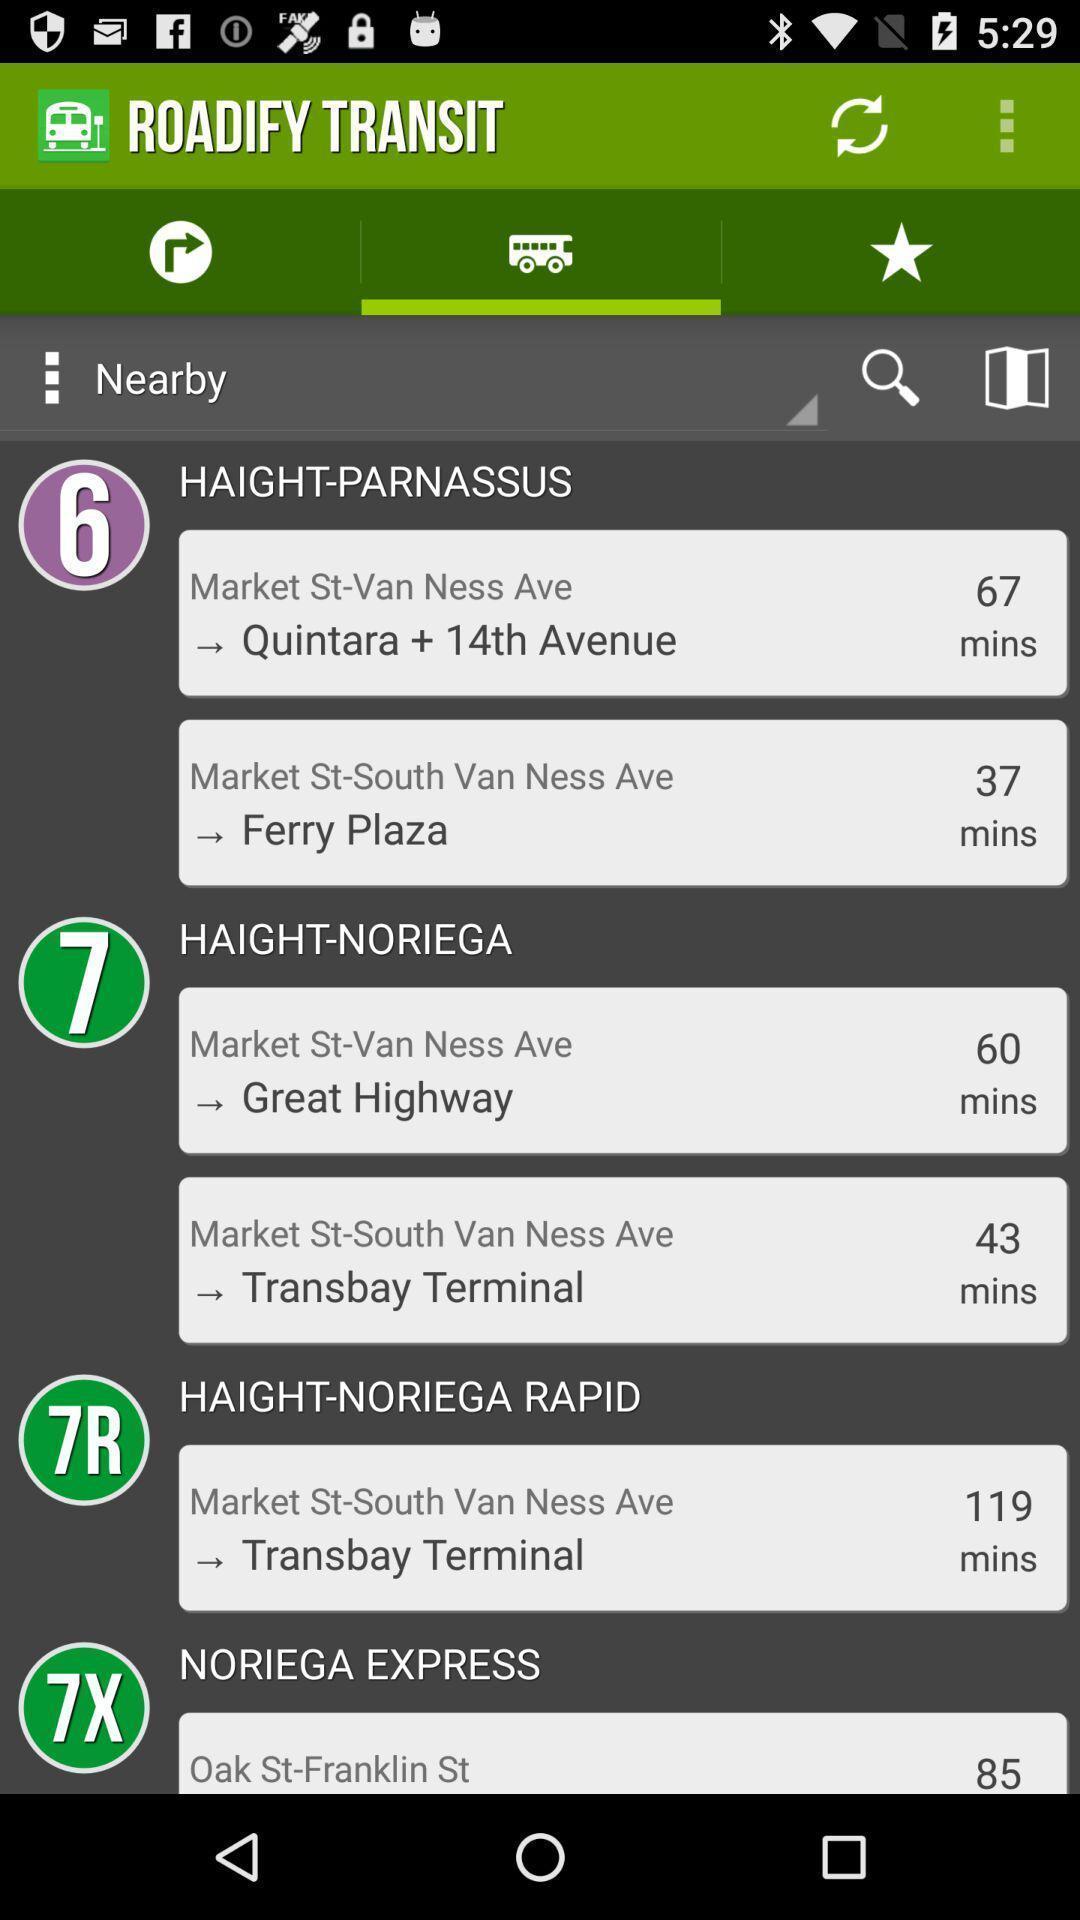Describe the visual elements of this screenshot. Screen shows details in a travel application. 